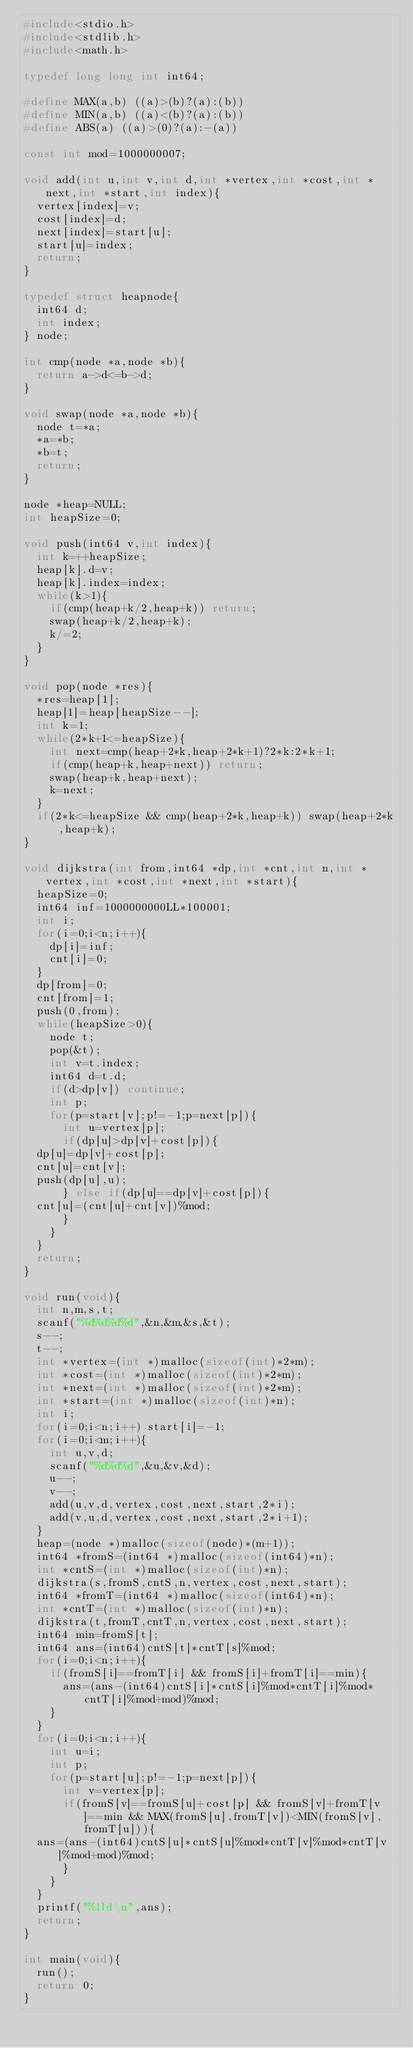Convert code to text. <code><loc_0><loc_0><loc_500><loc_500><_C_>#include<stdio.h>
#include<stdlib.h>
#include<math.h>

typedef long long int int64;

#define MAX(a,b) ((a)>(b)?(a):(b))
#define MIN(a,b) ((a)<(b)?(a):(b))
#define ABS(a) ((a)>(0)?(a):-(a))

const int mod=1000000007;

void add(int u,int v,int d,int *vertex,int *cost,int *next,int *start,int index){
  vertex[index]=v;
  cost[index]=d;
  next[index]=start[u];
  start[u]=index;
  return;
}

typedef struct heapnode{
  int64 d;
  int index;
} node;

int cmp(node *a,node *b){
  return a->d<=b->d;
}

void swap(node *a,node *b){
  node t=*a;
  *a=*b;
  *b=t;
  return;
}

node *heap=NULL;
int heapSize=0;

void push(int64 v,int index){
  int k=++heapSize;
  heap[k].d=v;
  heap[k].index=index;
  while(k>1){
    if(cmp(heap+k/2,heap+k)) return;
    swap(heap+k/2,heap+k);
    k/=2;
  }
}

void pop(node *res){
  *res=heap[1];
  heap[1]=heap[heapSize--];
  int k=1;
  while(2*k+1<=heapSize){
    int next=cmp(heap+2*k,heap+2*k+1)?2*k:2*k+1;
    if(cmp(heap+k,heap+next)) return;
    swap(heap+k,heap+next);
    k=next;
  }
  if(2*k<=heapSize && cmp(heap+2*k,heap+k)) swap(heap+2*k,heap+k);
}

void dijkstra(int from,int64 *dp,int *cnt,int n,int *vertex,int *cost,int *next,int *start){
  heapSize=0;
  int64 inf=1000000000LL*100001;
  int i;
  for(i=0;i<n;i++){
    dp[i]=inf;
    cnt[i]=0;
  }
  dp[from]=0;
  cnt[from]=1;
  push(0,from);
  while(heapSize>0){
    node t;
    pop(&t);
    int v=t.index;
    int64 d=t.d;
    if(d>dp[v]) continue;
    int p;
    for(p=start[v];p!=-1;p=next[p]){
      int u=vertex[p];
      if(dp[u]>dp[v]+cost[p]){
	dp[u]=dp[v]+cost[p];
	cnt[u]=cnt[v];
	push(dp[u],u);
      } else if(dp[u]==dp[v]+cost[p]){
	cnt[u]=(cnt[u]+cnt[v])%mod;
      }
    }
  }
  return;
}

void run(void){
  int n,m,s,t;
  scanf("%d%d%d%d",&n,&m,&s,&t);
  s--;
  t--;
  int *vertex=(int *)malloc(sizeof(int)*2*m);
  int *cost=(int *)malloc(sizeof(int)*2*m);
  int *next=(int *)malloc(sizeof(int)*2*m);
  int *start=(int *)malloc(sizeof(int)*n);
  int i;
  for(i=0;i<n;i++) start[i]=-1;
  for(i=0;i<m;i++){
    int u,v,d;
    scanf("%d%d%d",&u,&v,&d);
    u--;
    v--;
    add(u,v,d,vertex,cost,next,start,2*i);
    add(v,u,d,vertex,cost,next,start,2*i+1);
  }
  heap=(node *)malloc(sizeof(node)*(m+1));
  int64 *fromS=(int64 *)malloc(sizeof(int64)*n);
  int *cntS=(int *)malloc(sizeof(int)*n);
  dijkstra(s,fromS,cntS,n,vertex,cost,next,start);
  int64 *fromT=(int64 *)malloc(sizeof(int64)*n);
  int *cntT=(int *)malloc(sizeof(int)*n);
  dijkstra(t,fromT,cntT,n,vertex,cost,next,start);
  int64 min=fromS[t];
  int64 ans=(int64)cntS[t]*cntT[s]%mod;
  for(i=0;i<n;i++){
    if(fromS[i]==fromT[i] && fromS[i]+fromT[i]==min){
      ans=(ans-(int64)cntS[i]*cntS[i]%mod*cntT[i]%mod*cntT[i]%mod+mod)%mod;
    }
  }
  for(i=0;i<n;i++){
    int u=i;
    int p;
    for(p=start[u];p!=-1;p=next[p]){
      int v=vertex[p];
      if(fromS[v]==fromS[u]+cost[p] && fromS[v]+fromT[v]==min && MAX(fromS[u],fromT[v])<MIN(fromS[v],fromT[u])){
	ans=(ans-(int64)cntS[u]*cntS[u]%mod*cntT[v]%mod*cntT[v]%mod+mod)%mod;
      }
    }
  }
  printf("%lld\n",ans);
  return;
}

int main(void){
  run();
  return 0;
}
</code> 